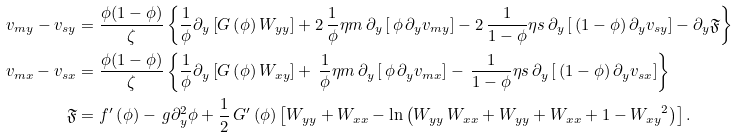Convert formula to latex. <formula><loc_0><loc_0><loc_500><loc_500>v _ { m y } - { v _ { s y } } & = \frac { \phi ( 1 - \phi ) } { \zeta } \left \{ \frac { 1 } { \phi } \partial _ { y } \left [ G \left ( \phi \right ) { W _ { y y } } \right ] + 2 \, \frac { 1 } { \phi } { \eta m } \, \partial _ { y } \left [ \, \phi \, \partial _ { y } { v _ { m y } } \right ] - 2 \, \frac { 1 } { 1 - \phi } { \eta s } \, \partial _ { y } \left [ \, \left ( 1 - \phi \right ) \partial _ { y } { v _ { s y } } \right ] - \partial _ { y } \mathfrak { F } \right \} \\ { v _ { m x } } - { v _ { s x } } & = \frac { \phi ( 1 - \phi ) } { \zeta } \left \{ \frac { 1 } { \phi } \partial _ { y } \left [ G \left ( \phi \right ) { W _ { x y } } \right ] + \, \frac { 1 } { \phi } { \eta m } \, \partial _ { y } \left [ \, \phi \, \partial _ { y } { v _ { m x } } \right ] - \, \frac { 1 } { 1 - \phi } { \eta s } \, \partial _ { y } \left [ \, \left ( 1 - \phi \right ) \partial _ { y } { v _ { s x } } \right ] \right \} \\ \mathfrak { F } & = { f ^ { \prime } } \left ( \phi \right ) - \, g \partial ^ { 2 } _ { y } \phi + \frac { 1 } { 2 } \, { G ^ { \prime } } \left ( \phi \right ) \left [ { W _ { y y } } + { W _ { x x } } - \ln \left ( { W _ { y y } } \, { W _ { x x } } + { W _ { y y } } + { W _ { x x } } + 1 - { { W _ { x y } } } ^ { 2 } \right ) \right ] .</formula> 